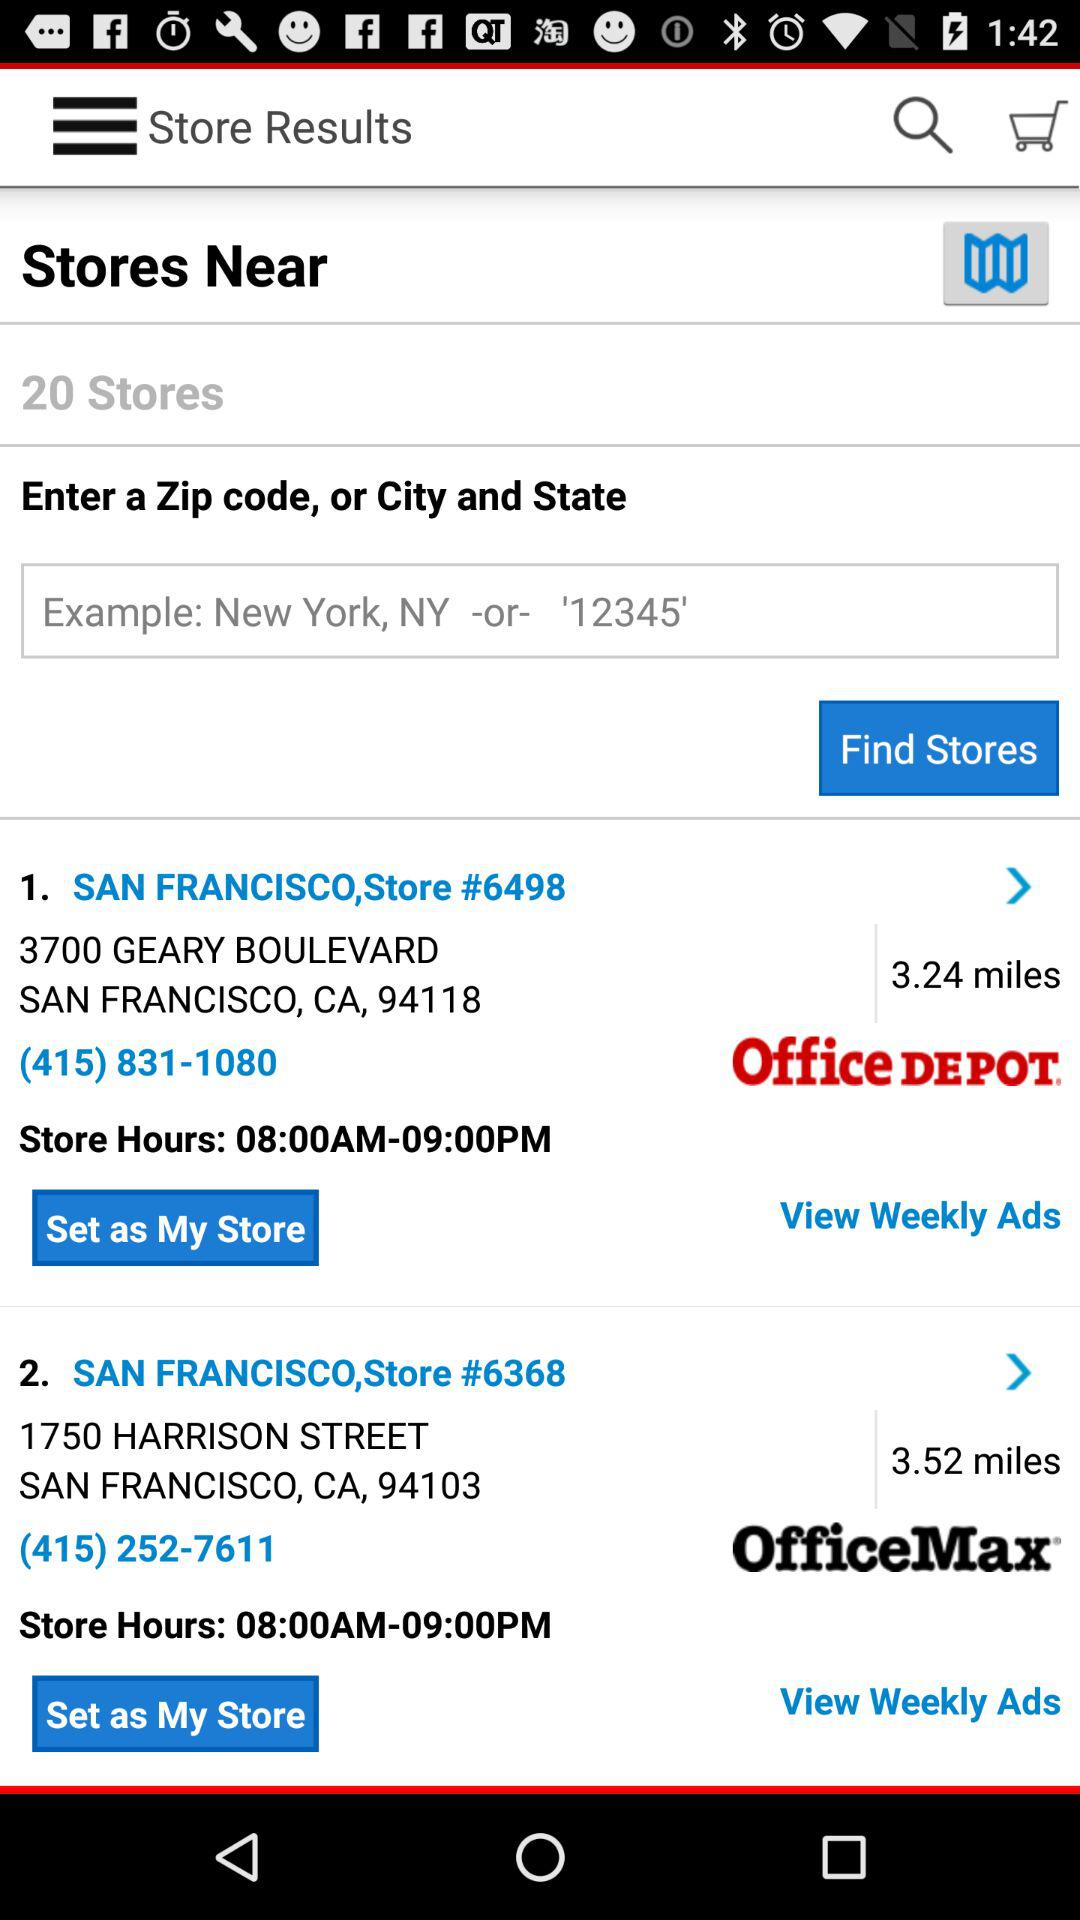What is the Zip code of the store number 6368? The Zip code of the store number 6368 is 94103. 